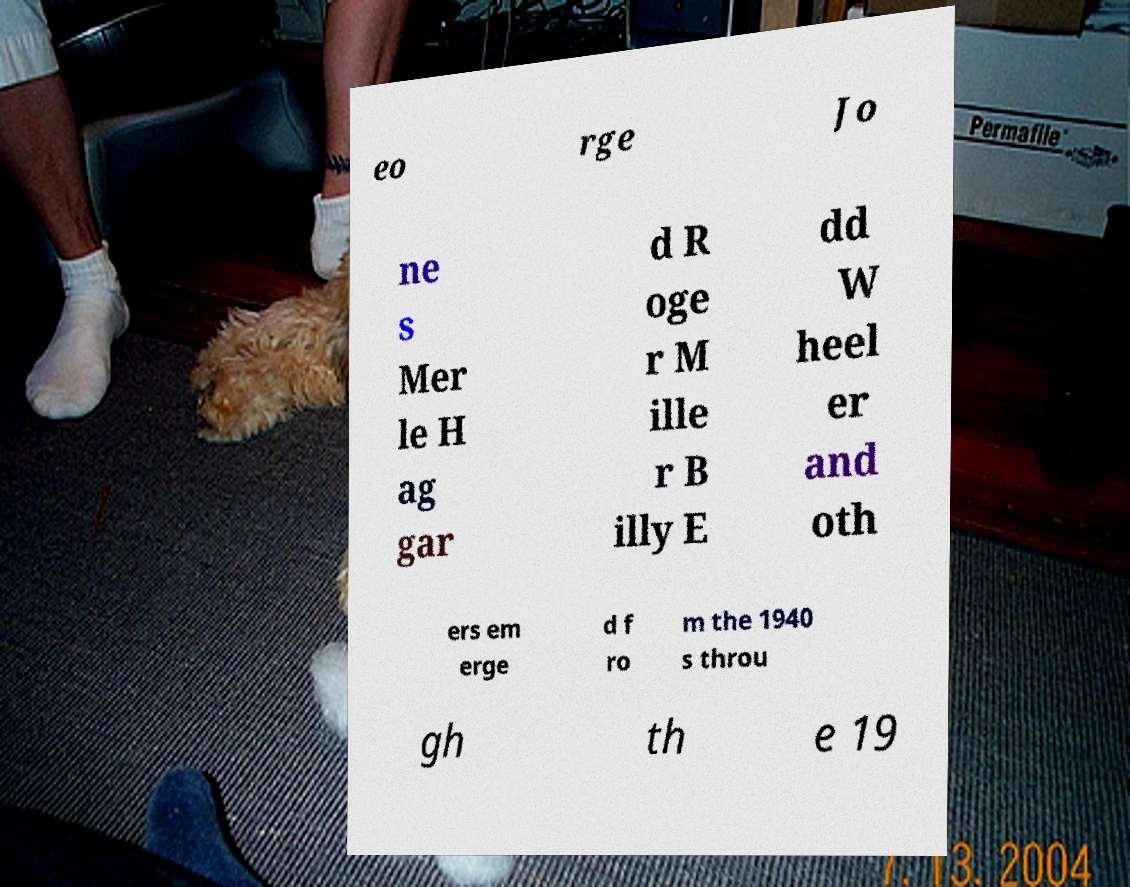Please identify and transcribe the text found in this image. eo rge Jo ne s Mer le H ag gar d R oge r M ille r B illy E dd W heel er and oth ers em erge d f ro m the 1940 s throu gh th e 19 